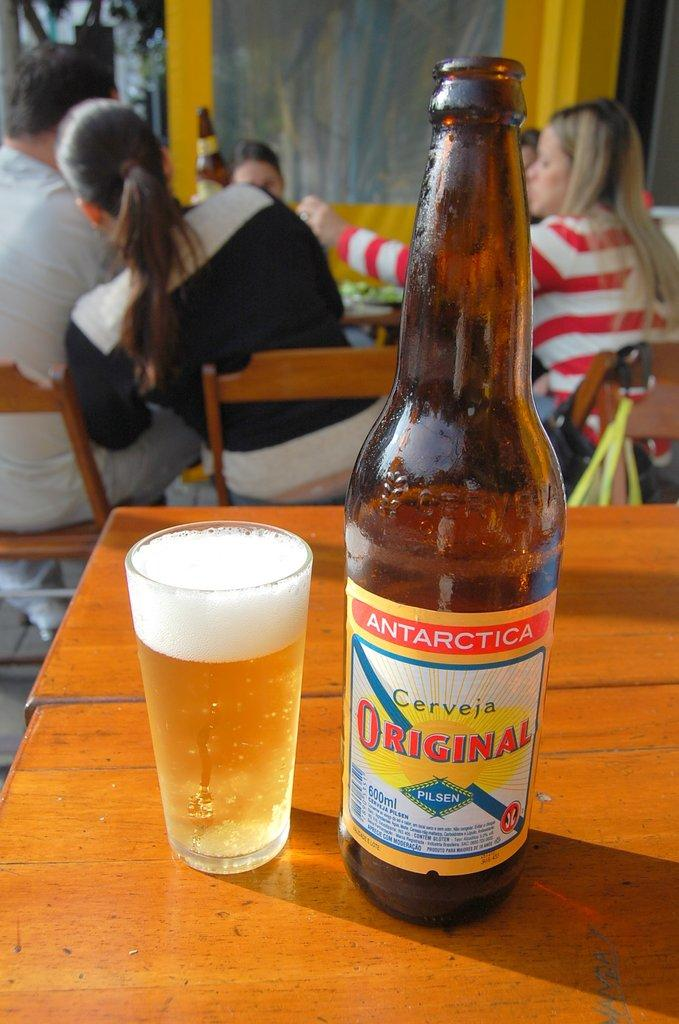<image>
Offer a succinct explanation of the picture presented. a glass and bottle of Antarctica Cerveja Original on a restaurant table 